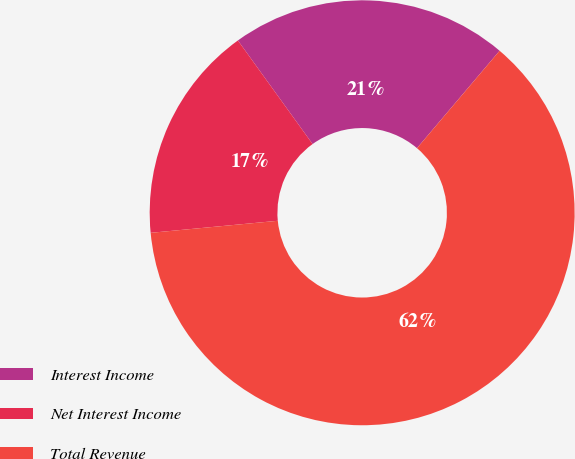Convert chart. <chart><loc_0><loc_0><loc_500><loc_500><pie_chart><fcel>Interest Income<fcel>Net Interest Income<fcel>Total Revenue<nl><fcel>21.14%<fcel>16.56%<fcel>62.3%<nl></chart> 